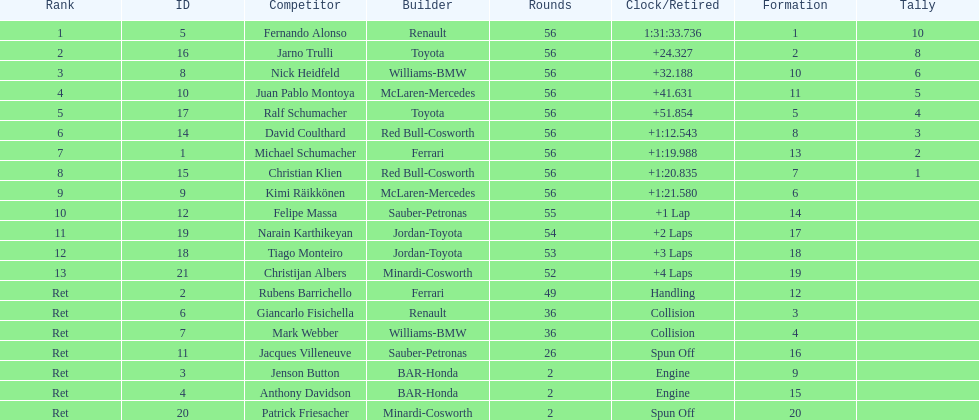How long did it take fernando alonso to finish the race? 1:31:33.736. 